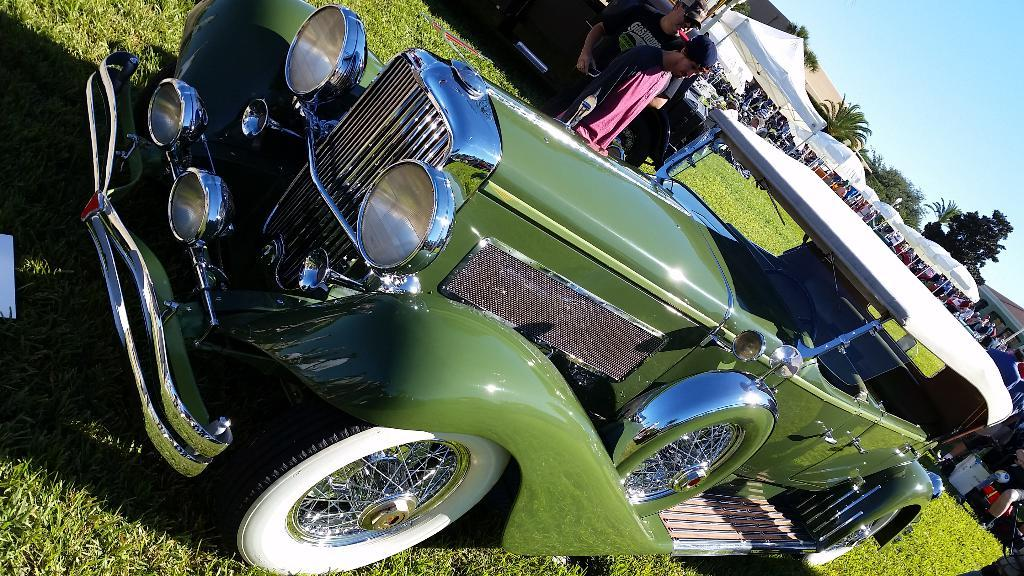What is the main subject in the middle of the image? There is a vehicle in the middle of the image. Who can be seen at the top of the image? There are two men at the top of the image. What can be observed on the right side of the image? There are many people, tents, grass, and trees on the right side of the image. What is visible at the top of the image? The sky is visible at the top of the image. How many goats are present in the image? There are no goats present in the image. What type of territory is being claimed by the men in the image? There is no indication of territory or any claim being made in the image. 